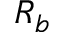<formula> <loc_0><loc_0><loc_500><loc_500>R _ { b }</formula> 